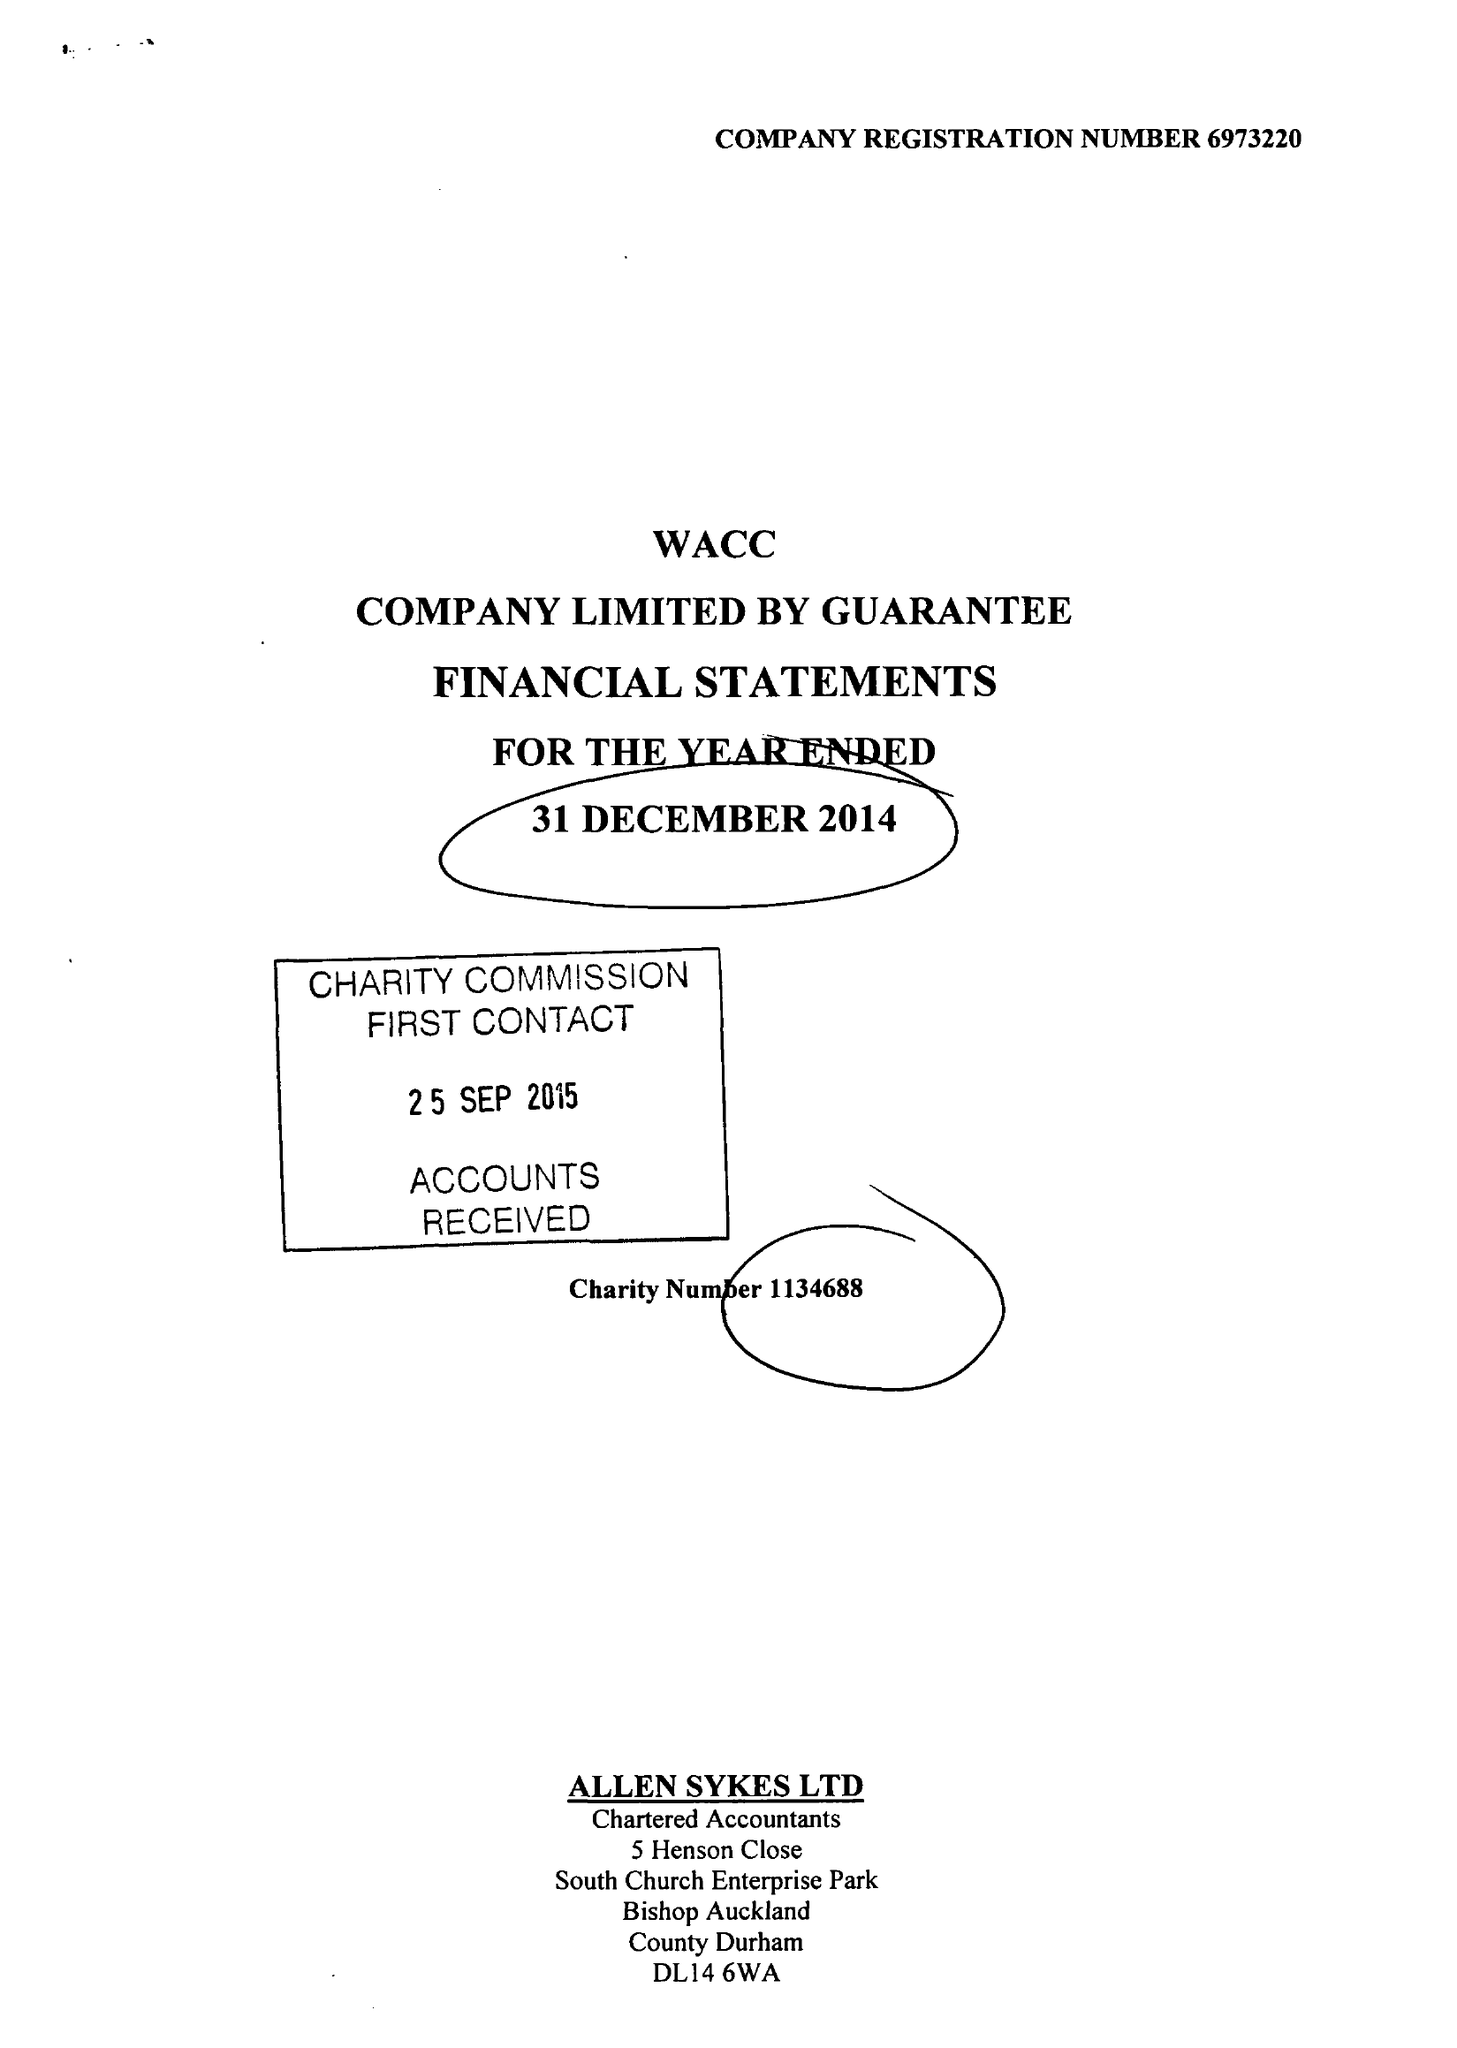What is the value for the address__street_line?
Answer the question using a single word or phrase. None 